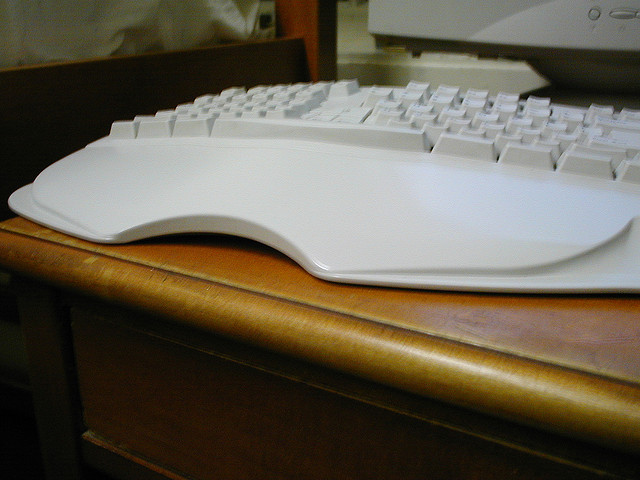<image>What is favori? I don't know what favori is. It can be food or keyboard. What is favori? I don't know what "favori" refers to. It can be food, keyboard, or laptop. 